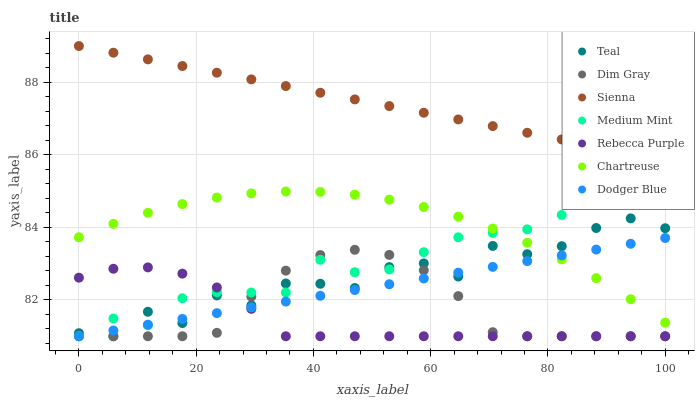Does Rebecca Purple have the minimum area under the curve?
Answer yes or no. Yes. Does Sienna have the maximum area under the curve?
Answer yes or no. Yes. Does Dim Gray have the minimum area under the curve?
Answer yes or no. No. Does Dim Gray have the maximum area under the curve?
Answer yes or no. No. Is Sienna the smoothest?
Answer yes or no. Yes. Is Teal the roughest?
Answer yes or no. Yes. Is Dim Gray the smoothest?
Answer yes or no. No. Is Dim Gray the roughest?
Answer yes or no. No. Does Medium Mint have the lowest value?
Answer yes or no. Yes. Does Sienna have the lowest value?
Answer yes or no. No. Does Sienna have the highest value?
Answer yes or no. Yes. Does Dim Gray have the highest value?
Answer yes or no. No. Is Dim Gray less than Sienna?
Answer yes or no. Yes. Is Sienna greater than Teal?
Answer yes or no. Yes. Does Medium Mint intersect Teal?
Answer yes or no. Yes. Is Medium Mint less than Teal?
Answer yes or no. No. Is Medium Mint greater than Teal?
Answer yes or no. No. Does Dim Gray intersect Sienna?
Answer yes or no. No. 